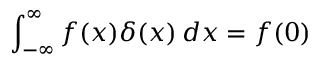<formula> <loc_0><loc_0><loc_500><loc_500>\int _ { - \infty } ^ { \infty } f ( x ) \delta ( x ) \, d x = f ( 0 )</formula> 